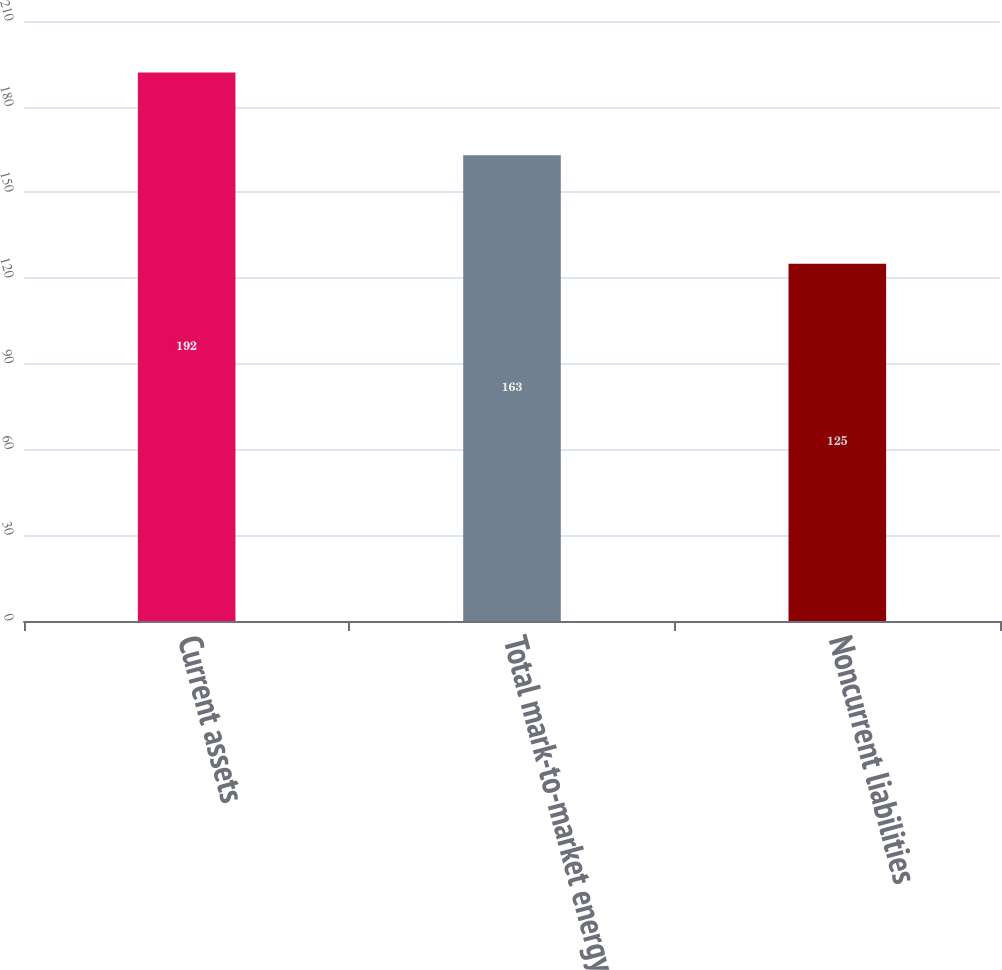Convert chart. <chart><loc_0><loc_0><loc_500><loc_500><bar_chart><fcel>Current assets<fcel>Total mark-to-market energy<fcel>Noncurrent liabilities<nl><fcel>192<fcel>163<fcel>125<nl></chart> 